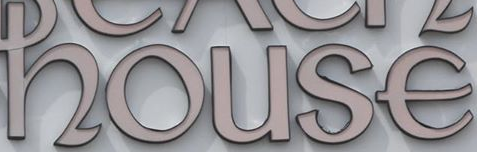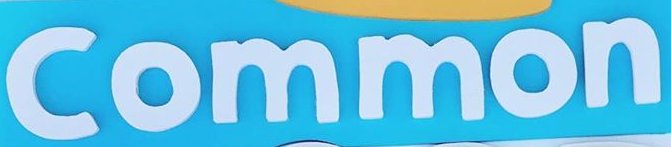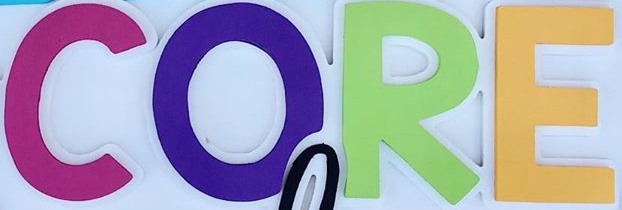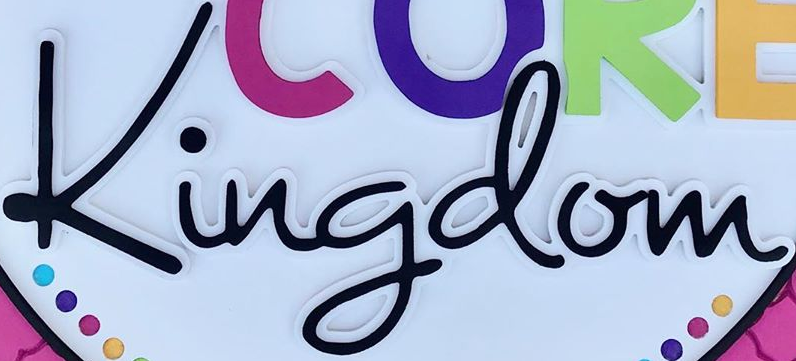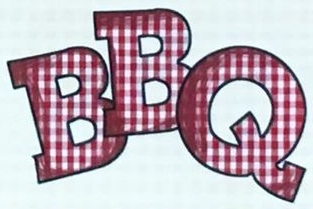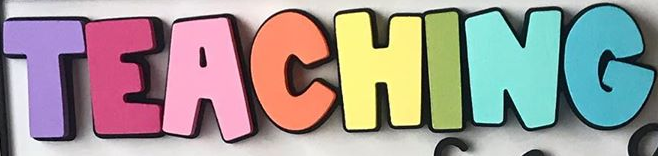Read the text from these images in sequence, separated by a semicolon. house; Common; CORE; Kingdom; BBQ; TEACHING 